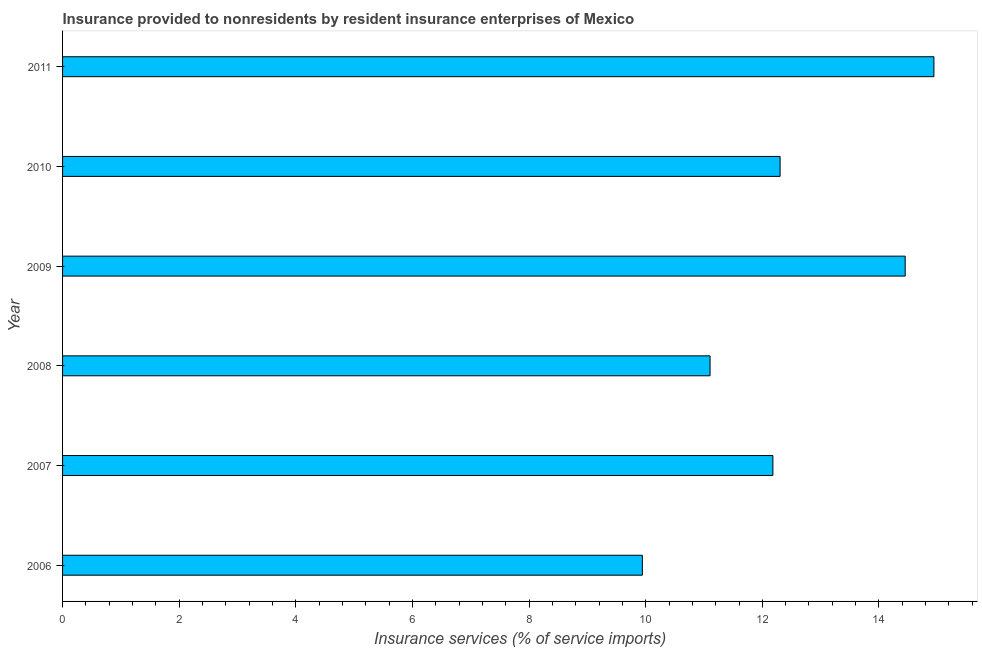Does the graph contain any zero values?
Offer a very short reply. No. Does the graph contain grids?
Keep it short and to the point. No. What is the title of the graph?
Keep it short and to the point. Insurance provided to nonresidents by resident insurance enterprises of Mexico. What is the label or title of the X-axis?
Give a very brief answer. Insurance services (% of service imports). What is the insurance and financial services in 2011?
Offer a very short reply. 14.94. Across all years, what is the maximum insurance and financial services?
Offer a very short reply. 14.94. Across all years, what is the minimum insurance and financial services?
Make the answer very short. 9.94. In which year was the insurance and financial services maximum?
Ensure brevity in your answer.  2011. What is the sum of the insurance and financial services?
Provide a short and direct response. 74.92. What is the difference between the insurance and financial services in 2007 and 2010?
Give a very brief answer. -0.12. What is the average insurance and financial services per year?
Provide a short and direct response. 12.49. What is the median insurance and financial services?
Offer a terse response. 12.24. In how many years, is the insurance and financial services greater than 10.4 %?
Provide a succinct answer. 5. What is the ratio of the insurance and financial services in 2008 to that in 2011?
Make the answer very short. 0.74. Is the difference between the insurance and financial services in 2007 and 2009 greater than the difference between any two years?
Make the answer very short. No. What is the difference between the highest and the second highest insurance and financial services?
Ensure brevity in your answer.  0.49. What is the difference between the highest and the lowest insurance and financial services?
Your answer should be compact. 5. In how many years, is the insurance and financial services greater than the average insurance and financial services taken over all years?
Your response must be concise. 2. What is the difference between two consecutive major ticks on the X-axis?
Make the answer very short. 2. Are the values on the major ticks of X-axis written in scientific E-notation?
Make the answer very short. No. What is the Insurance services (% of service imports) in 2006?
Provide a short and direct response. 9.94. What is the Insurance services (% of service imports) of 2007?
Offer a very short reply. 12.18. What is the Insurance services (% of service imports) of 2008?
Your answer should be compact. 11.1. What is the Insurance services (% of service imports) of 2009?
Make the answer very short. 14.45. What is the Insurance services (% of service imports) of 2010?
Offer a terse response. 12.3. What is the Insurance services (% of service imports) in 2011?
Ensure brevity in your answer.  14.94. What is the difference between the Insurance services (% of service imports) in 2006 and 2007?
Give a very brief answer. -2.24. What is the difference between the Insurance services (% of service imports) in 2006 and 2008?
Offer a very short reply. -1.16. What is the difference between the Insurance services (% of service imports) in 2006 and 2009?
Give a very brief answer. -4.51. What is the difference between the Insurance services (% of service imports) in 2006 and 2010?
Offer a very short reply. -2.36. What is the difference between the Insurance services (% of service imports) in 2006 and 2011?
Offer a very short reply. -5. What is the difference between the Insurance services (% of service imports) in 2007 and 2008?
Your answer should be very brief. 1.08. What is the difference between the Insurance services (% of service imports) in 2007 and 2009?
Give a very brief answer. -2.27. What is the difference between the Insurance services (% of service imports) in 2007 and 2010?
Your answer should be compact. -0.12. What is the difference between the Insurance services (% of service imports) in 2007 and 2011?
Ensure brevity in your answer.  -2.76. What is the difference between the Insurance services (% of service imports) in 2008 and 2009?
Your answer should be very brief. -3.35. What is the difference between the Insurance services (% of service imports) in 2008 and 2010?
Provide a short and direct response. -1.2. What is the difference between the Insurance services (% of service imports) in 2008 and 2011?
Provide a short and direct response. -3.84. What is the difference between the Insurance services (% of service imports) in 2009 and 2010?
Offer a very short reply. 2.15. What is the difference between the Insurance services (% of service imports) in 2009 and 2011?
Keep it short and to the point. -0.49. What is the difference between the Insurance services (% of service imports) in 2010 and 2011?
Offer a terse response. -2.64. What is the ratio of the Insurance services (% of service imports) in 2006 to that in 2007?
Offer a very short reply. 0.82. What is the ratio of the Insurance services (% of service imports) in 2006 to that in 2008?
Make the answer very short. 0.9. What is the ratio of the Insurance services (% of service imports) in 2006 to that in 2009?
Offer a very short reply. 0.69. What is the ratio of the Insurance services (% of service imports) in 2006 to that in 2010?
Your answer should be very brief. 0.81. What is the ratio of the Insurance services (% of service imports) in 2006 to that in 2011?
Give a very brief answer. 0.67. What is the ratio of the Insurance services (% of service imports) in 2007 to that in 2008?
Your answer should be very brief. 1.1. What is the ratio of the Insurance services (% of service imports) in 2007 to that in 2009?
Provide a succinct answer. 0.84. What is the ratio of the Insurance services (% of service imports) in 2007 to that in 2011?
Your answer should be very brief. 0.81. What is the ratio of the Insurance services (% of service imports) in 2008 to that in 2009?
Make the answer very short. 0.77. What is the ratio of the Insurance services (% of service imports) in 2008 to that in 2010?
Your answer should be compact. 0.9. What is the ratio of the Insurance services (% of service imports) in 2008 to that in 2011?
Keep it short and to the point. 0.74. What is the ratio of the Insurance services (% of service imports) in 2009 to that in 2010?
Provide a short and direct response. 1.17. What is the ratio of the Insurance services (% of service imports) in 2010 to that in 2011?
Your answer should be compact. 0.82. 